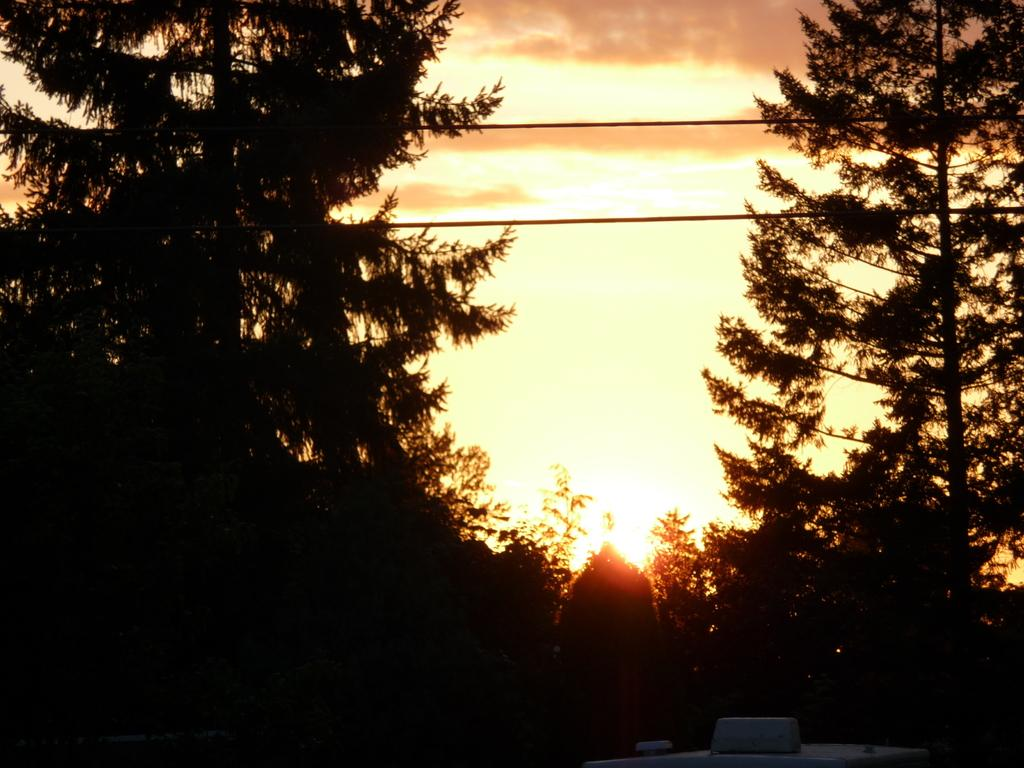What type of vegetation can be seen in the image? There are trees in the image. What else can be seen in the image besides trees? There are poles with wires attached in the image. What is visible in the background of the image? The sky is visible in the background of the image. Can the sun be seen in the image? Yes, the sun is observable in the sky. What type of meat is being cooked on the steam in the image? There is no steam or meat present in the image. 